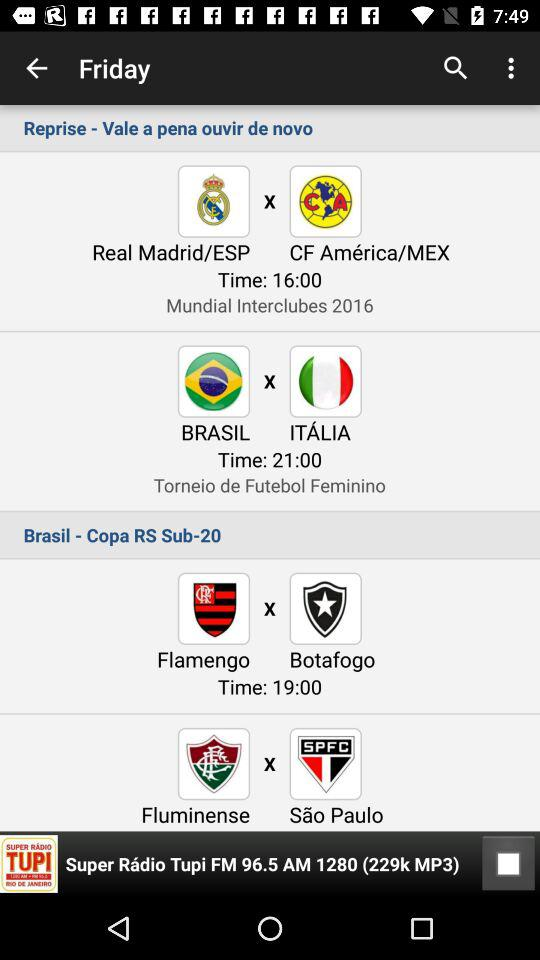How many items have a time?
Answer the question using a single word or phrase. 3 